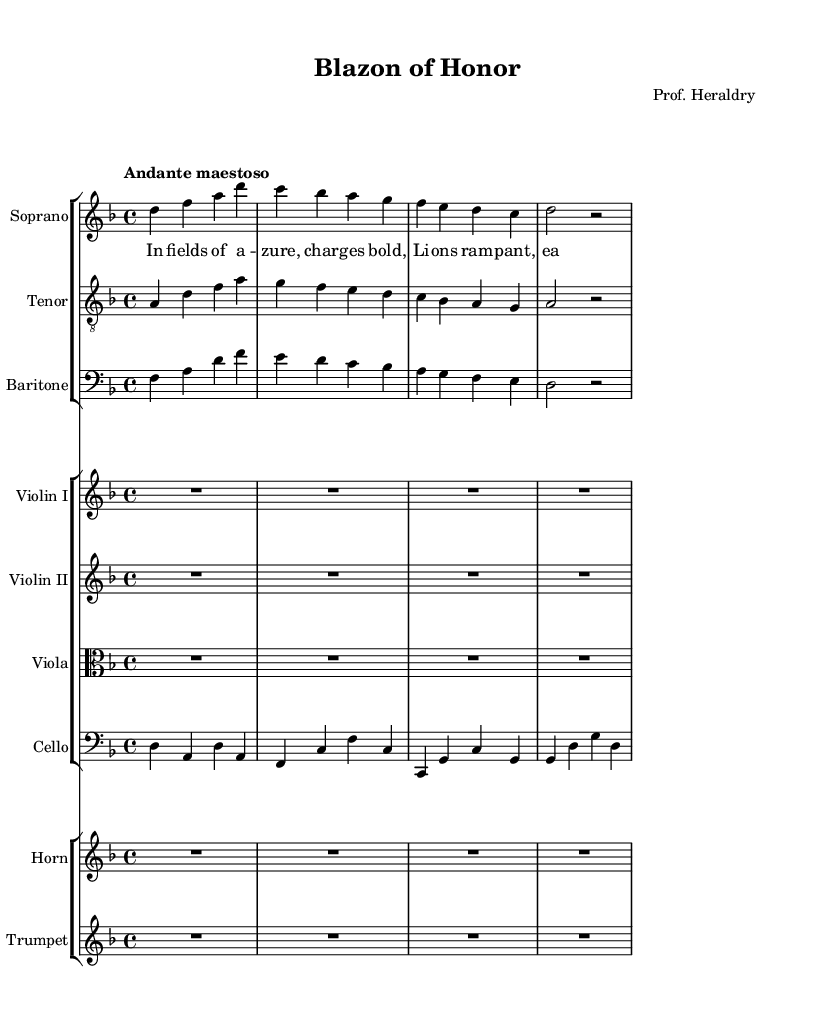What is the key signature of this music? The key signature indicated shows two flats, which is characteristic of D minor.
Answer: D minor What is the time signature of the piece? The time signature displayed at the beginning of the score indicates that each measure contains four beats, which is represented as 4/4.
Answer: 4/4 What is the tempo marking for this composition? The tempo marking written above the score suggests a slow and dignified speed, specified as "Andante maestoso."
Answer: Andante maestoso How many voices are present in the vocal parts? In the vocal sections of the score, three distinct voice parts: Soprano, Tenor, and Baritone, are shown leading to a total of three.
Answer: Three What instruments are included in the orchestration? The score lists several string and brass instruments, including two violins, a viola, a cello, a horn, and a trumpet, outlining the orchestral makeup.
Answer: Strings and Brass Which voice has the highest pitch in this composition? Comparing the written ranges, the Soprano has the highest range of notes among the vocal parts indicated in the score.
Answer: Soprano What thematic imagery is suggested by the lyrics in the verse section? The lyrics describe bold charges with images of azure fields and golden eagles, suggesting themes of nobility and honor, likely reflecting the significance of heraldry.
Answer: Nobility and Honor 